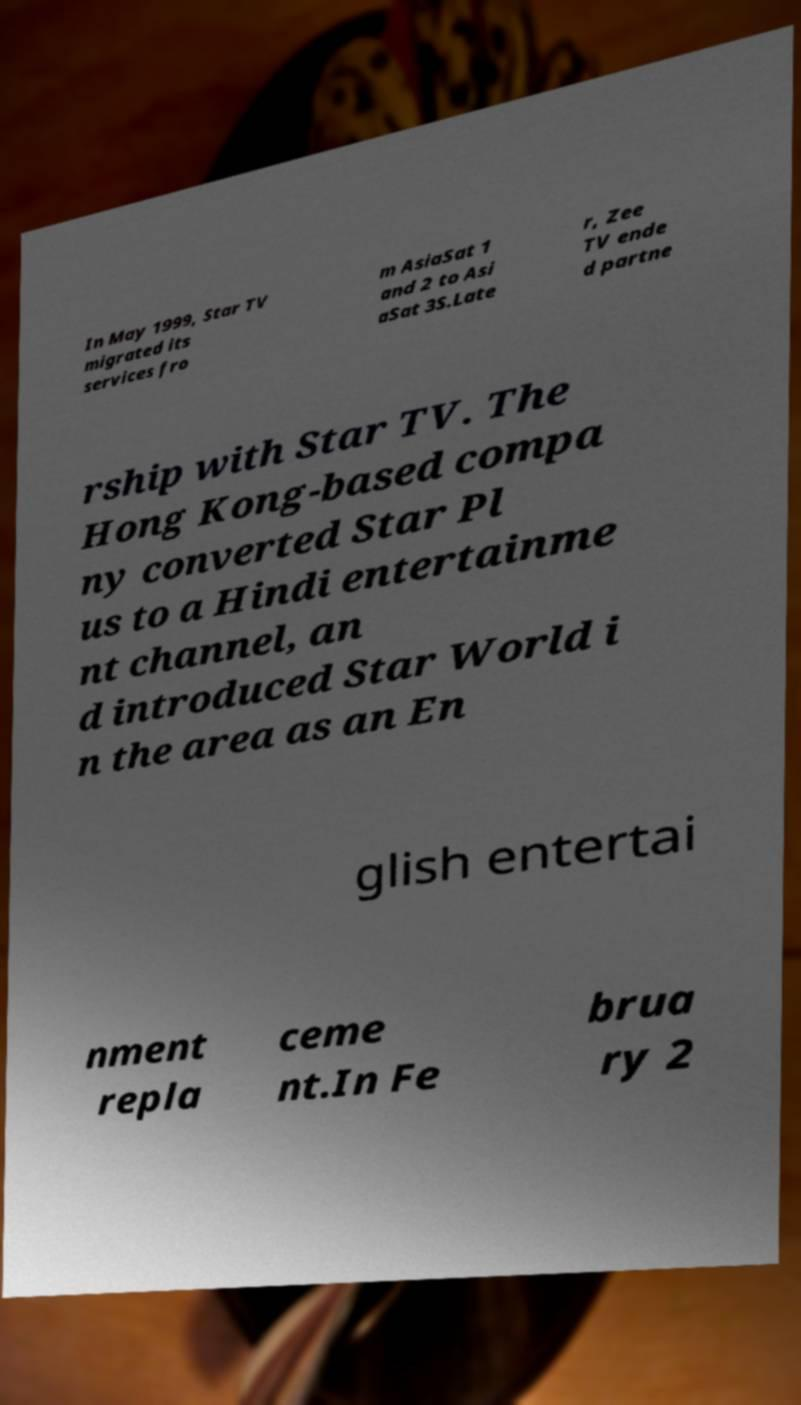For documentation purposes, I need the text within this image transcribed. Could you provide that? In May 1999, Star TV migrated its services fro m AsiaSat 1 and 2 to Asi aSat 3S.Late r, Zee TV ende d partne rship with Star TV. The Hong Kong-based compa ny converted Star Pl us to a Hindi entertainme nt channel, an d introduced Star World i n the area as an En glish entertai nment repla ceme nt.In Fe brua ry 2 